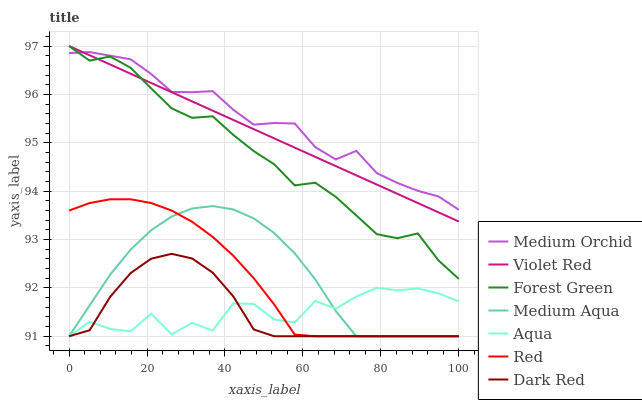Does Dark Red have the minimum area under the curve?
Answer yes or no. Yes. Does Medium Orchid have the maximum area under the curve?
Answer yes or no. Yes. Does Medium Orchid have the minimum area under the curve?
Answer yes or no. No. Does Dark Red have the maximum area under the curve?
Answer yes or no. No. Is Violet Red the smoothest?
Answer yes or no. Yes. Is Aqua the roughest?
Answer yes or no. Yes. Is Dark Red the smoothest?
Answer yes or no. No. Is Dark Red the roughest?
Answer yes or no. No. Does Medium Orchid have the lowest value?
Answer yes or no. No. Does Forest Green have the highest value?
Answer yes or no. Yes. Does Dark Red have the highest value?
Answer yes or no. No. Is Aqua less than Violet Red?
Answer yes or no. Yes. Is Violet Red greater than Red?
Answer yes or no. Yes. Does Dark Red intersect Red?
Answer yes or no. Yes. Is Dark Red less than Red?
Answer yes or no. No. Is Dark Red greater than Red?
Answer yes or no. No. Does Aqua intersect Violet Red?
Answer yes or no. No. 